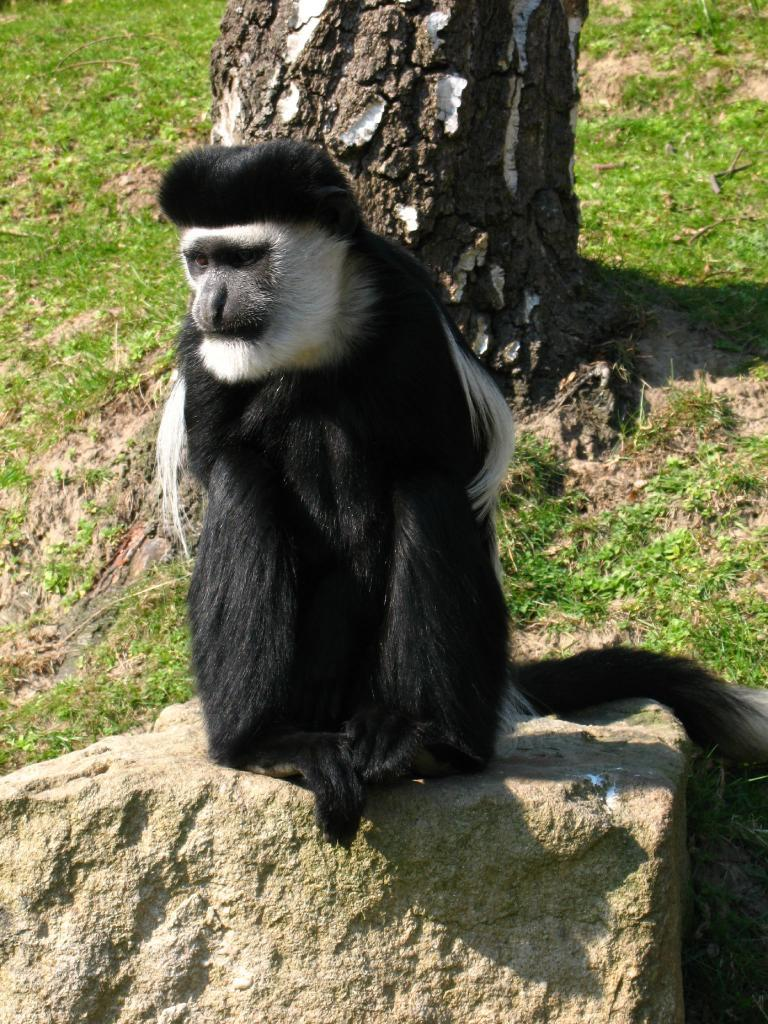What is the main object in the image? There is a stone in the image. What is on top of the stone? There is a black and white monkey on the stone. What can be seen in the background of the image? There is grass and a tree trunk in the background of the image. How does the monkey skate on the stone in the image? The monkey does not skate on the stone in the image; it is sitting on the stone. 